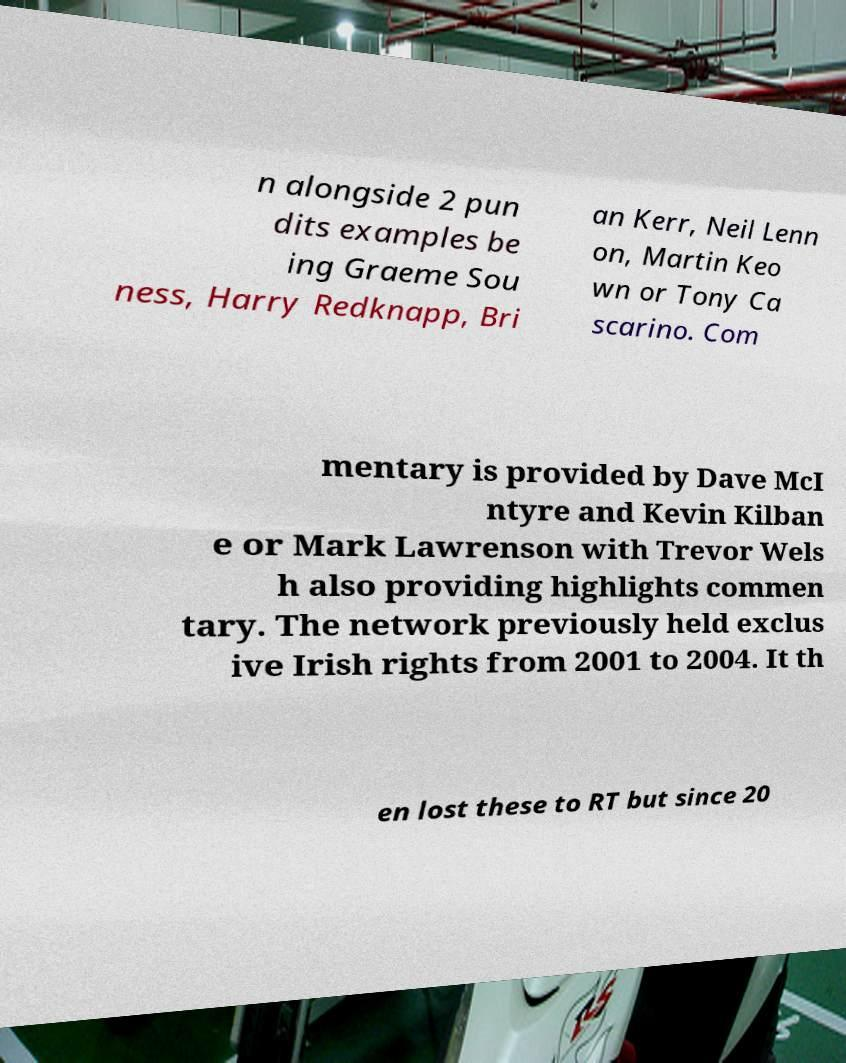Can you accurately transcribe the text from the provided image for me? n alongside 2 pun dits examples be ing Graeme Sou ness, Harry Redknapp, Bri an Kerr, Neil Lenn on, Martin Keo wn or Tony Ca scarino. Com mentary is provided by Dave McI ntyre and Kevin Kilban e or Mark Lawrenson with Trevor Wels h also providing highlights commen tary. The network previously held exclus ive Irish rights from 2001 to 2004. It th en lost these to RT but since 20 